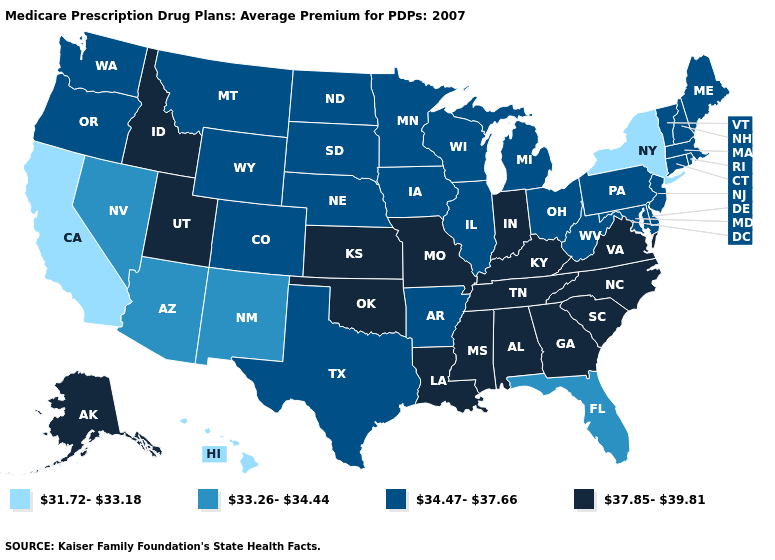What is the value of New York?
Write a very short answer. 31.72-33.18. Name the states that have a value in the range 37.85-39.81?
Keep it brief. Alaska, Alabama, Georgia, Idaho, Indiana, Kansas, Kentucky, Louisiana, Missouri, Mississippi, North Carolina, Oklahoma, South Carolina, Tennessee, Utah, Virginia. What is the lowest value in states that border Maryland?
Write a very short answer. 34.47-37.66. What is the value of Arizona?
Quick response, please. 33.26-34.44. Does the map have missing data?
Be succinct. No. Does Alaska have a higher value than Georgia?
Concise answer only. No. What is the lowest value in the USA?
Concise answer only. 31.72-33.18. What is the value of Oklahoma?
Give a very brief answer. 37.85-39.81. Does Alaska have the lowest value in the West?
Keep it brief. No. Among the states that border Massachusetts , does Connecticut have the lowest value?
Concise answer only. No. How many symbols are there in the legend?
Concise answer only. 4. Name the states that have a value in the range 33.26-34.44?
Quick response, please. Arizona, Florida, New Mexico, Nevada. What is the value of New Mexico?
Keep it brief. 33.26-34.44. Which states hav the highest value in the MidWest?
Be succinct. Indiana, Kansas, Missouri. 